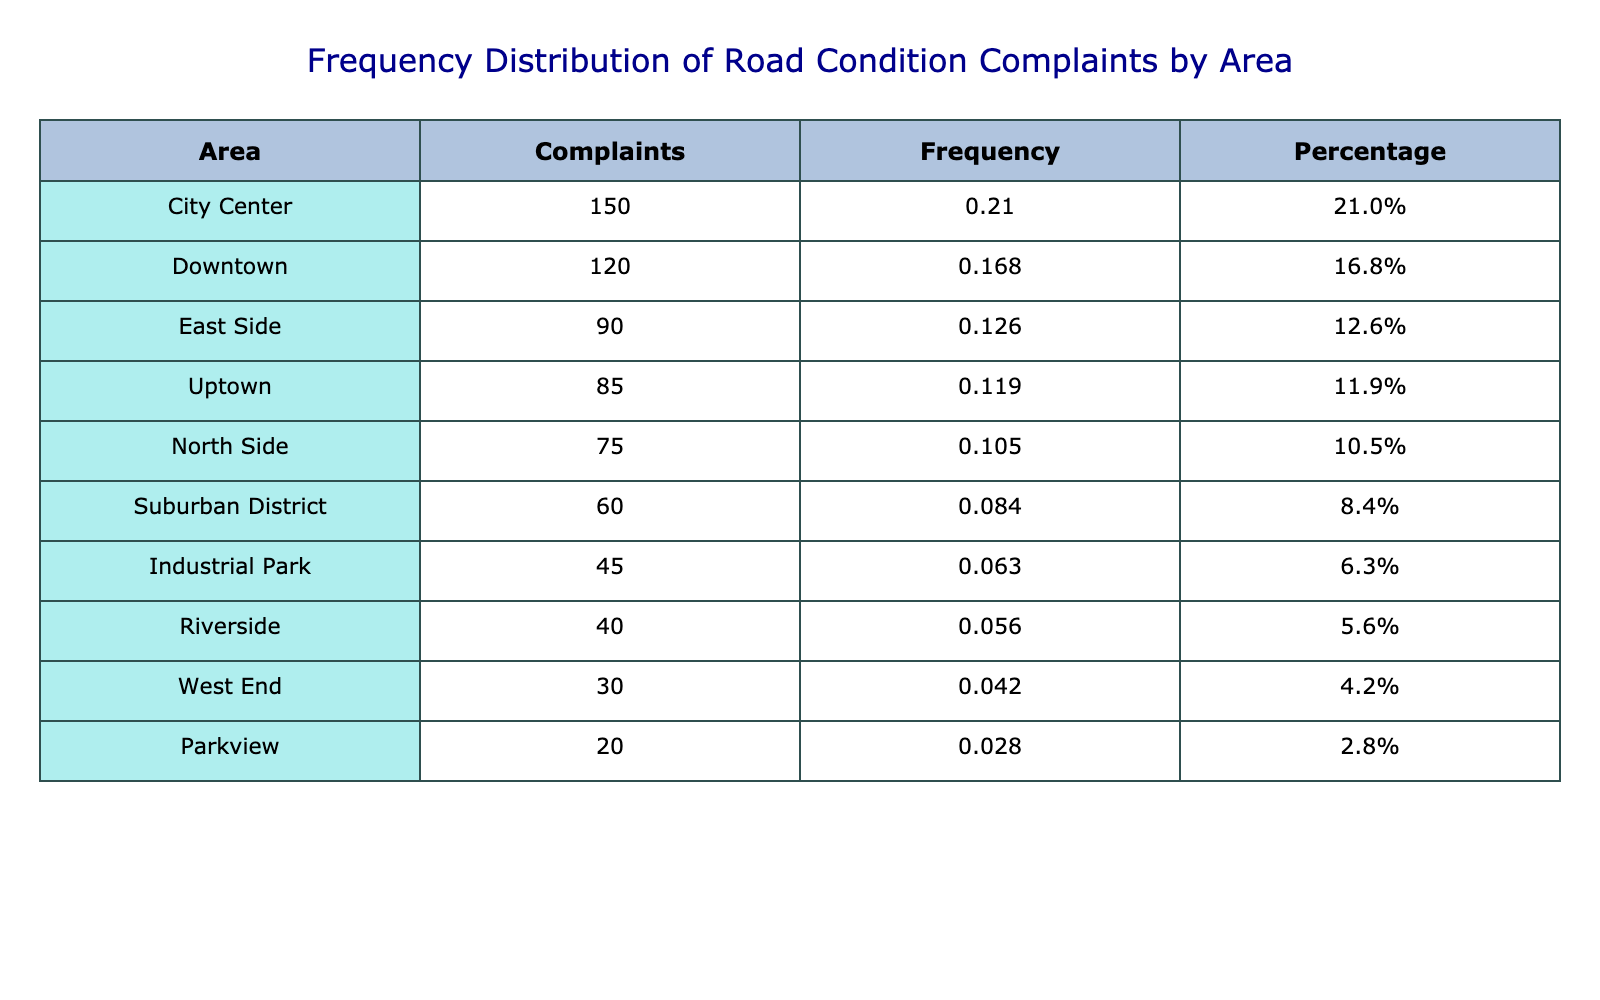What area received the highest number of complaints? To determine the area with the highest number of complaints, we can look at the "Complaints Received" column. The highest value is 150, which corresponds to "City Center."
Answer: City Center Which area received the fewest complaints? By examining the "Complaints Received" column, we can see that the lowest value is 20, associated with "Parkview."
Answer: Parkview What percentage of total complaints came from the Industrial Park? First, we calculate the total complaints, which is 600 (120 + 85 + 60 + 45 + 150 + 75 + 30 + 90 + 40 + 20). The complaints from Industrial Park are 45. The percentage calculation is (45 / 600) * 100 = 7.5%.
Answer: 7.5% Are there more complaints in Downtown than in the North Side? The number of complaints in Downtown is 120, and in North Side, it is 75. Since 120 is greater than 75, the answer is yes.
Answer: Yes What is the average number of complaints across all areas? To find the average, we sum all the complaints, which is 600, and divide by the number of areas (10). Thus, the average is 600 / 10 = 60.
Answer: 60 Which two areas combined received more complaints than the City Center? The City Center has 150 complaints. By examining pairs, "Downtown" (120) and "Uptown" (85) total 205, which is more than 150.
Answer: Downtown and Uptown What is the total number of complaints received from the East Side and Riverside combined? The complaints from East Side are 90 and from Riverside are 40. Adding these two values gives us 90 + 40 = 130.
Answer: 130 Is the percentage of complaints in the West End greater than 5%? The total number of complaints is 600, and West End has 30 complaints. The percentage is (30 / 600) * 100 = 5%. Since 5% is not greater than 5%, the answer is no.
Answer: No 